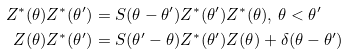Convert formula to latex. <formula><loc_0><loc_0><loc_500><loc_500>Z ^ { \ast } ( \theta ) Z ^ { \ast } ( \theta ^ { \prime } ) & = S ( \theta - \theta ^ { \prime } ) Z ^ { \ast } ( \theta ^ { \prime } ) Z ^ { \ast } ( \theta ) , \, \theta < \theta ^ { \prime } \\ Z ( \theta ) Z ^ { \ast } ( \theta ^ { \prime } ) & = S ( \theta ^ { \prime } - \theta ) Z ^ { \ast } ( \theta ^ { \prime } ) Z ( \theta ) + \delta ( \theta - \theta ^ { \prime } )</formula> 